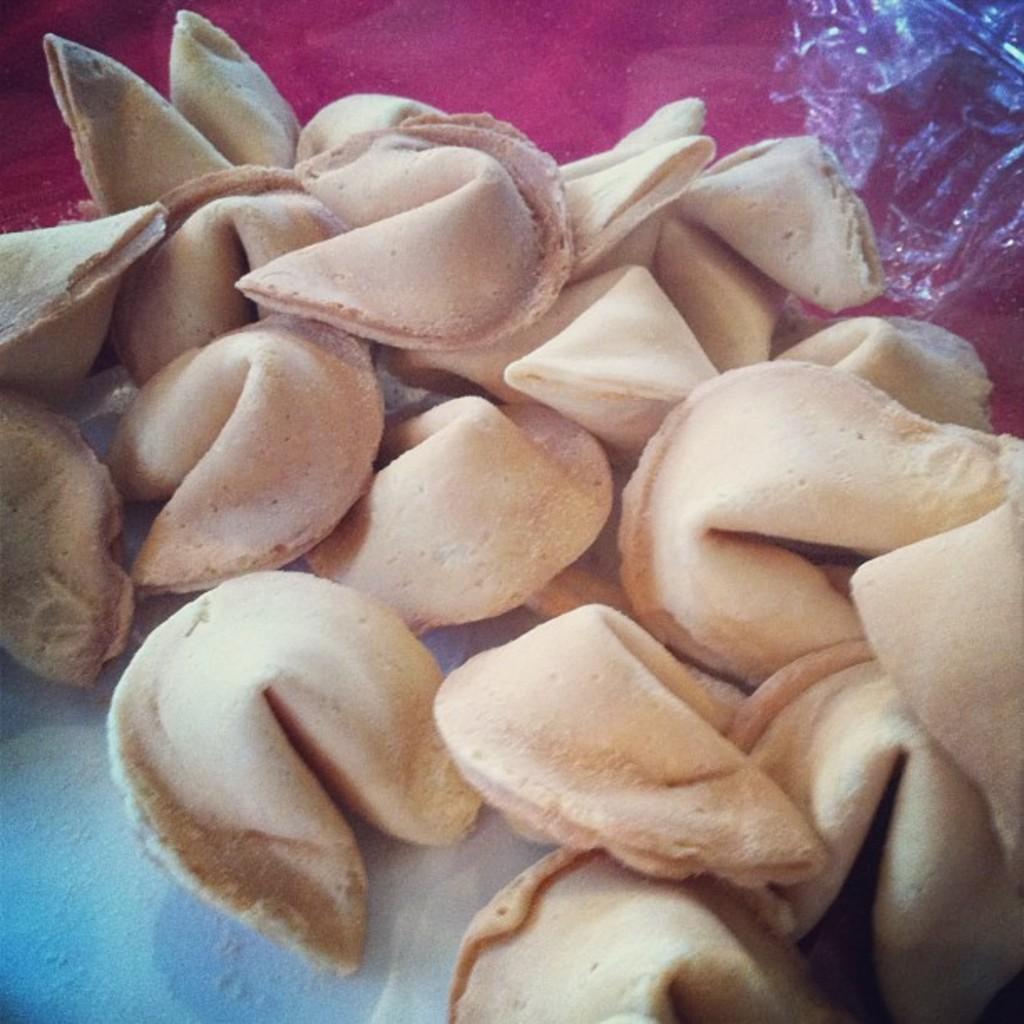Can you describe this image briefly? In this image we can see raw dumplings. 